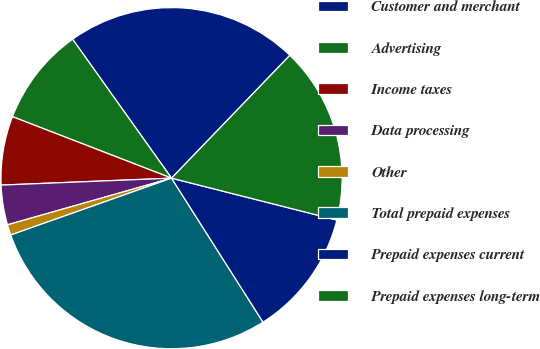Convert chart. <chart><loc_0><loc_0><loc_500><loc_500><pie_chart><fcel>Customer and merchant<fcel>Advertising<fcel>Income taxes<fcel>Data processing<fcel>Other<fcel>Total prepaid expenses<fcel>Prepaid expenses current<fcel>Prepaid expenses long-term<nl><fcel>22.05%<fcel>9.28%<fcel>6.52%<fcel>3.76%<fcel>1.0%<fcel>28.6%<fcel>12.04%<fcel>16.75%<nl></chart> 